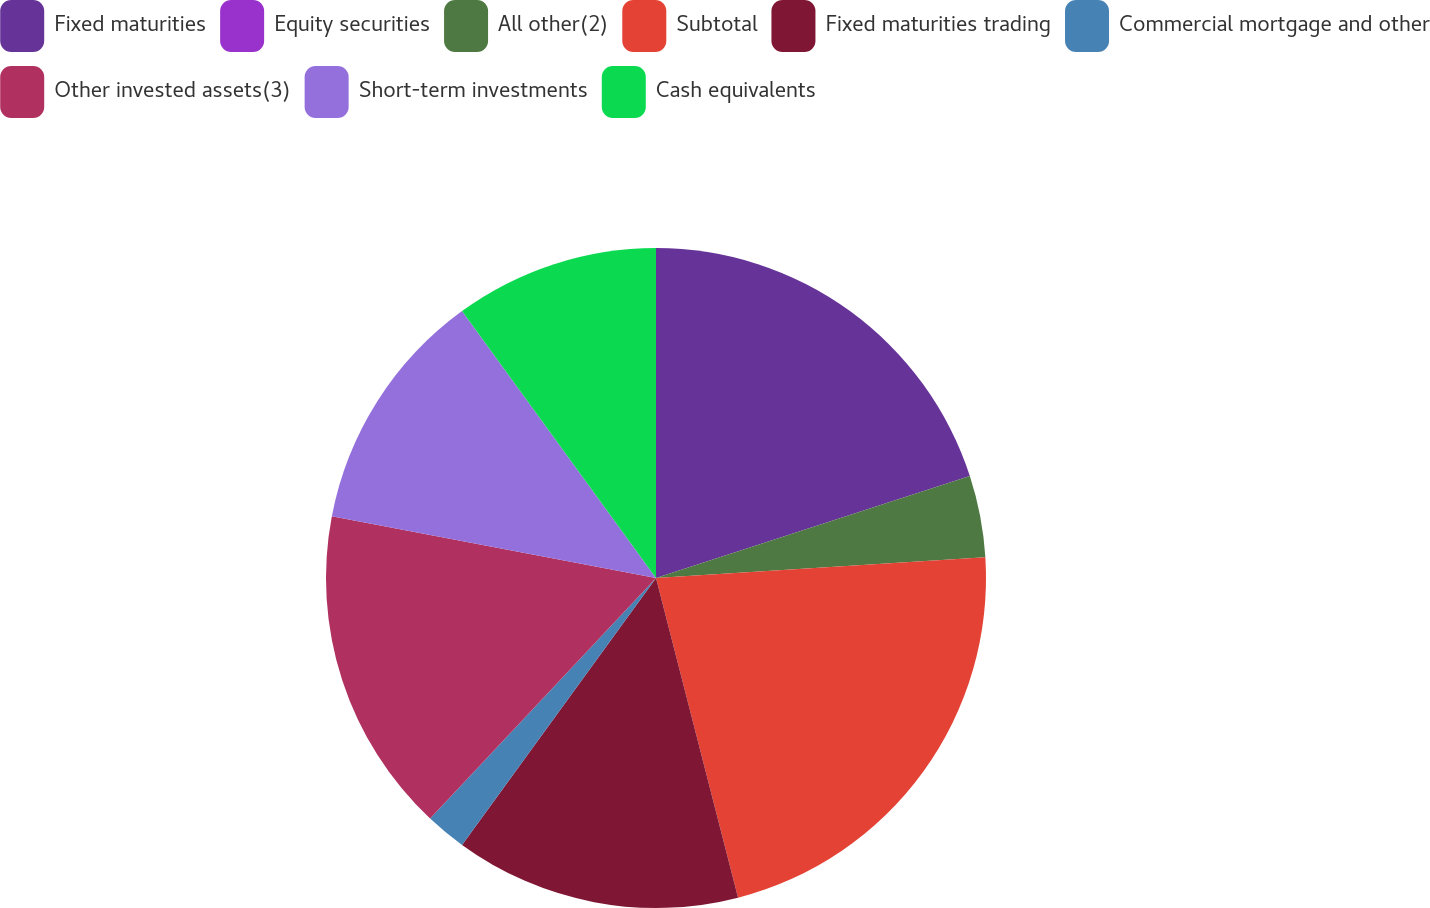<chart> <loc_0><loc_0><loc_500><loc_500><pie_chart><fcel>Fixed maturities<fcel>Equity securities<fcel>All other(2)<fcel>Subtotal<fcel>Fixed maturities trading<fcel>Commercial mortgage and other<fcel>Other invested assets(3)<fcel>Short-term investments<fcel>Cash equivalents<nl><fcel>20.0%<fcel>0.0%<fcel>4.0%<fcel>22.0%<fcel>14.0%<fcel>2.0%<fcel>16.0%<fcel>12.0%<fcel>10.0%<nl></chart> 